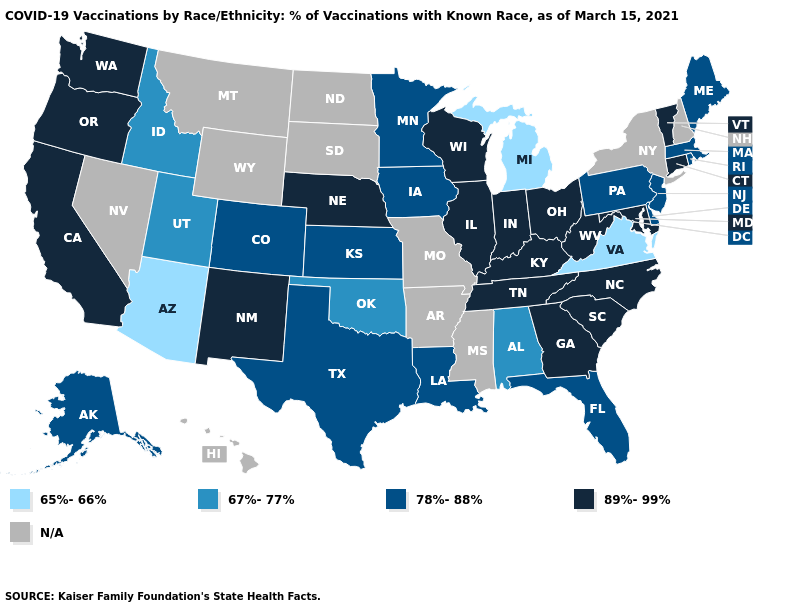Does Vermont have the lowest value in the Northeast?
Answer briefly. No. What is the highest value in the USA?
Concise answer only. 89%-99%. Name the states that have a value in the range 89%-99%?
Keep it brief. California, Connecticut, Georgia, Illinois, Indiana, Kentucky, Maryland, Nebraska, New Mexico, North Carolina, Ohio, Oregon, South Carolina, Tennessee, Vermont, Washington, West Virginia, Wisconsin. Which states have the lowest value in the USA?
Be succinct. Arizona, Michigan, Virginia. How many symbols are there in the legend?
Be succinct. 5. Which states have the lowest value in the USA?
Short answer required. Arizona, Michigan, Virginia. Does Utah have the highest value in the USA?
Give a very brief answer. No. Does Kansas have the highest value in the MidWest?
Be succinct. No. Does Virginia have the lowest value in the USA?
Be succinct. Yes. What is the value of Colorado?
Be succinct. 78%-88%. Which states have the lowest value in the USA?
Give a very brief answer. Arizona, Michigan, Virginia. Does the first symbol in the legend represent the smallest category?
Short answer required. Yes. Which states have the lowest value in the MidWest?
Quick response, please. Michigan. What is the value of Nevada?
Give a very brief answer. N/A. 